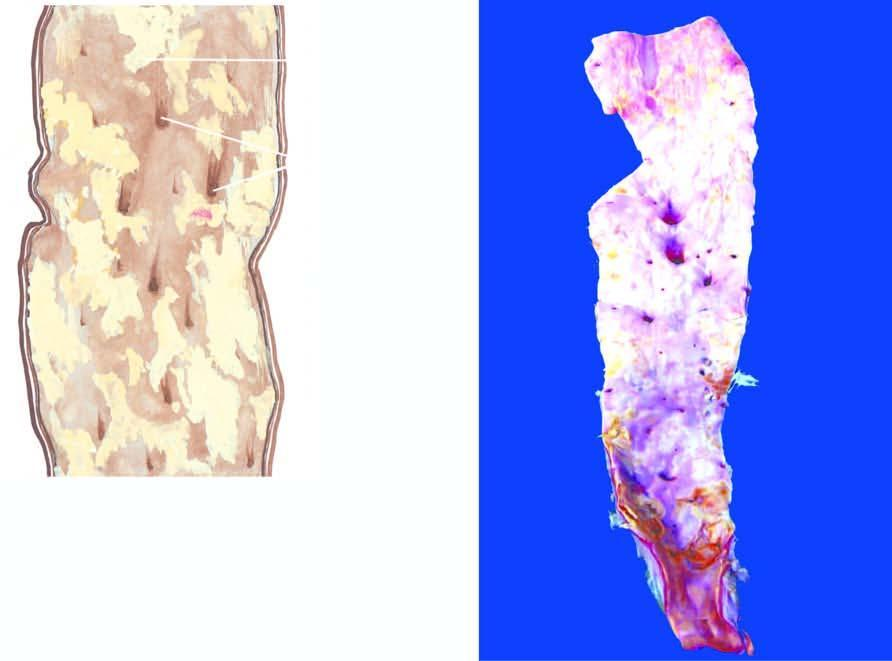what are raised yellowish-white lesions raised above the surface?
Answer the question using a single word or phrase. Some 